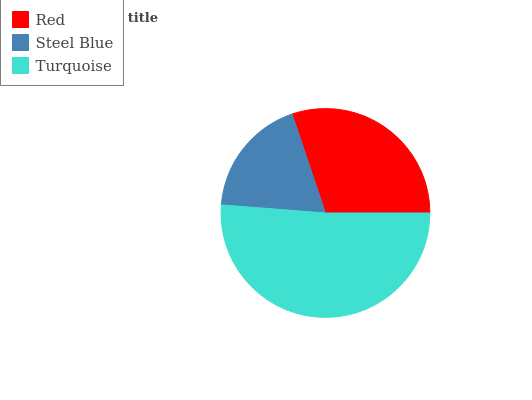Is Steel Blue the minimum?
Answer yes or no. Yes. Is Turquoise the maximum?
Answer yes or no. Yes. Is Turquoise the minimum?
Answer yes or no. No. Is Steel Blue the maximum?
Answer yes or no. No. Is Turquoise greater than Steel Blue?
Answer yes or no. Yes. Is Steel Blue less than Turquoise?
Answer yes or no. Yes. Is Steel Blue greater than Turquoise?
Answer yes or no. No. Is Turquoise less than Steel Blue?
Answer yes or no. No. Is Red the high median?
Answer yes or no. Yes. Is Red the low median?
Answer yes or no. Yes. Is Turquoise the high median?
Answer yes or no. No. Is Turquoise the low median?
Answer yes or no. No. 